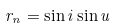Convert formula to latex. <formula><loc_0><loc_0><loc_500><loc_500>r _ { n } = \sin i \sin u</formula> 